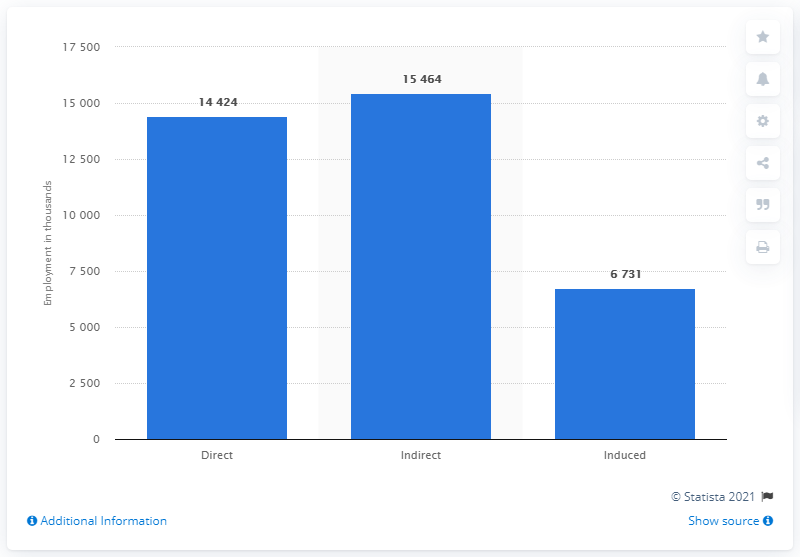Highlight a few significant elements in this photo. The difference between indirect and direct taxes lies in the way they are collected, with indirect taxes being collected through the price of a good or service and direct taxes being collected as a percentage of income or wealth. The graph has been represented for the year 2017. 